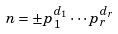<formula> <loc_0><loc_0><loc_500><loc_500>n = \pm p _ { 1 } ^ { d _ { 1 } } \cdot \cdot \cdot p _ { r } ^ { d _ { r } }</formula> 